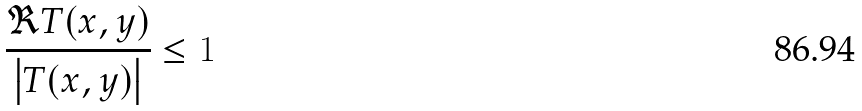<formula> <loc_0><loc_0><loc_500><loc_500>\frac { \Re T ( x , y ) } { \left | T ( x , y ) \right | } \leq 1</formula> 